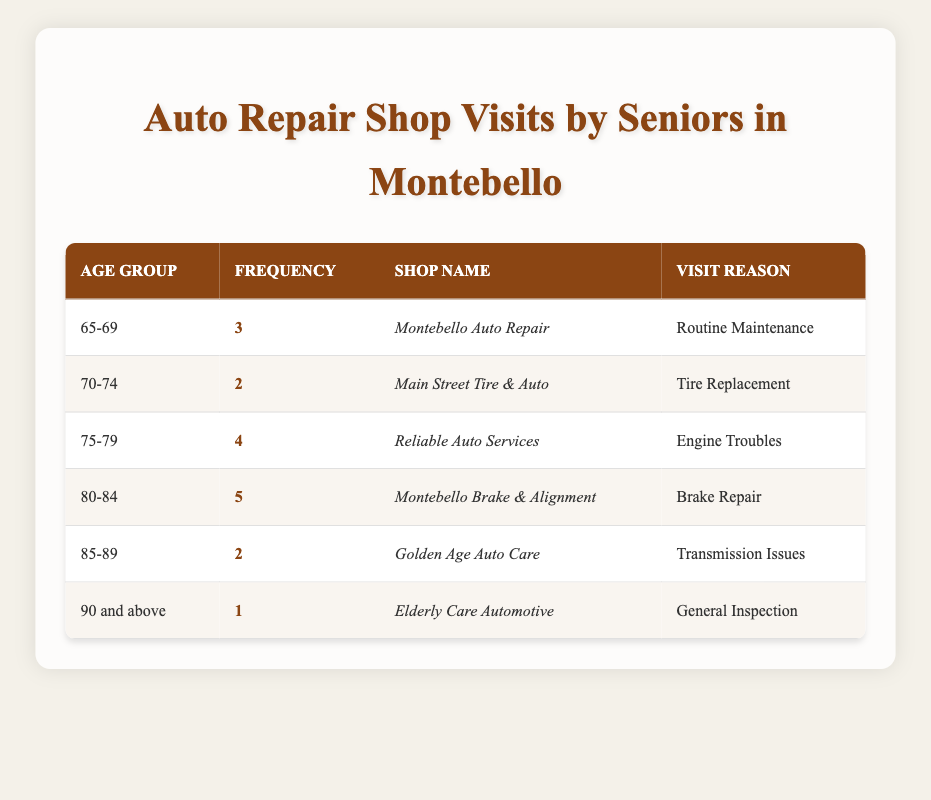What is the frequency of repair shop visits for the age group 80-84? The table states that for the age group 80-84, the frequency of repair shop visits is listed under the "Frequency" column, which shows a value of 5.
Answer: 5 Which repair shop had the most visits? By examining the "Frequency" column, the highest number is 5, found in the row for the shop "Montebello Brake & Alignment."
Answer: Montebello Brake & Alignment Is there a shop that caters specifically to senior citizens aged 90 and above? Yes, the table shows a specific entry for the age group "90 and above" with the shop "Elderly Care Automotive," which indicates that this shop caters to this age group.
Answer: Yes What is the total frequency of visits for senior citizens aged 75 and older? To find this, we need to sum the frequencies for the age groups 75-79 (4), 80-84 (5), and 85-89 (2). The total is calculated as 4 + 5 + 2 = 11.
Answer: 11 Is the reason for visiting "Routine Maintenance" unique to any age group? Yes, the reason "Routine Maintenance" appears only in the age group 65-69 for the shop "Montebello Auto Repair," making it unique to that age group in this table.
Answer: Yes What is the average frequency of shop visits across all age groups listed? To calculate the average, we sum all frequencies (3 + 2 + 4 + 5 + 2 + 1 = 17) and divide by the number of age groups (6). The average is 17 / 6, which equals approximately 2.83.
Answer: Approximately 2.83 Which age group has the least shop visits and what is the frequency? By looking through the "Frequency" column, "90 and above" has the least frequency, with a value of 1.
Answer: 90 and above, 1 Do any repair shops have zero visits recorded in the table? No, the table lists frequencies for all age groups that show at least one visit recorded, indicating that no shop has zero visits.
Answer: No 